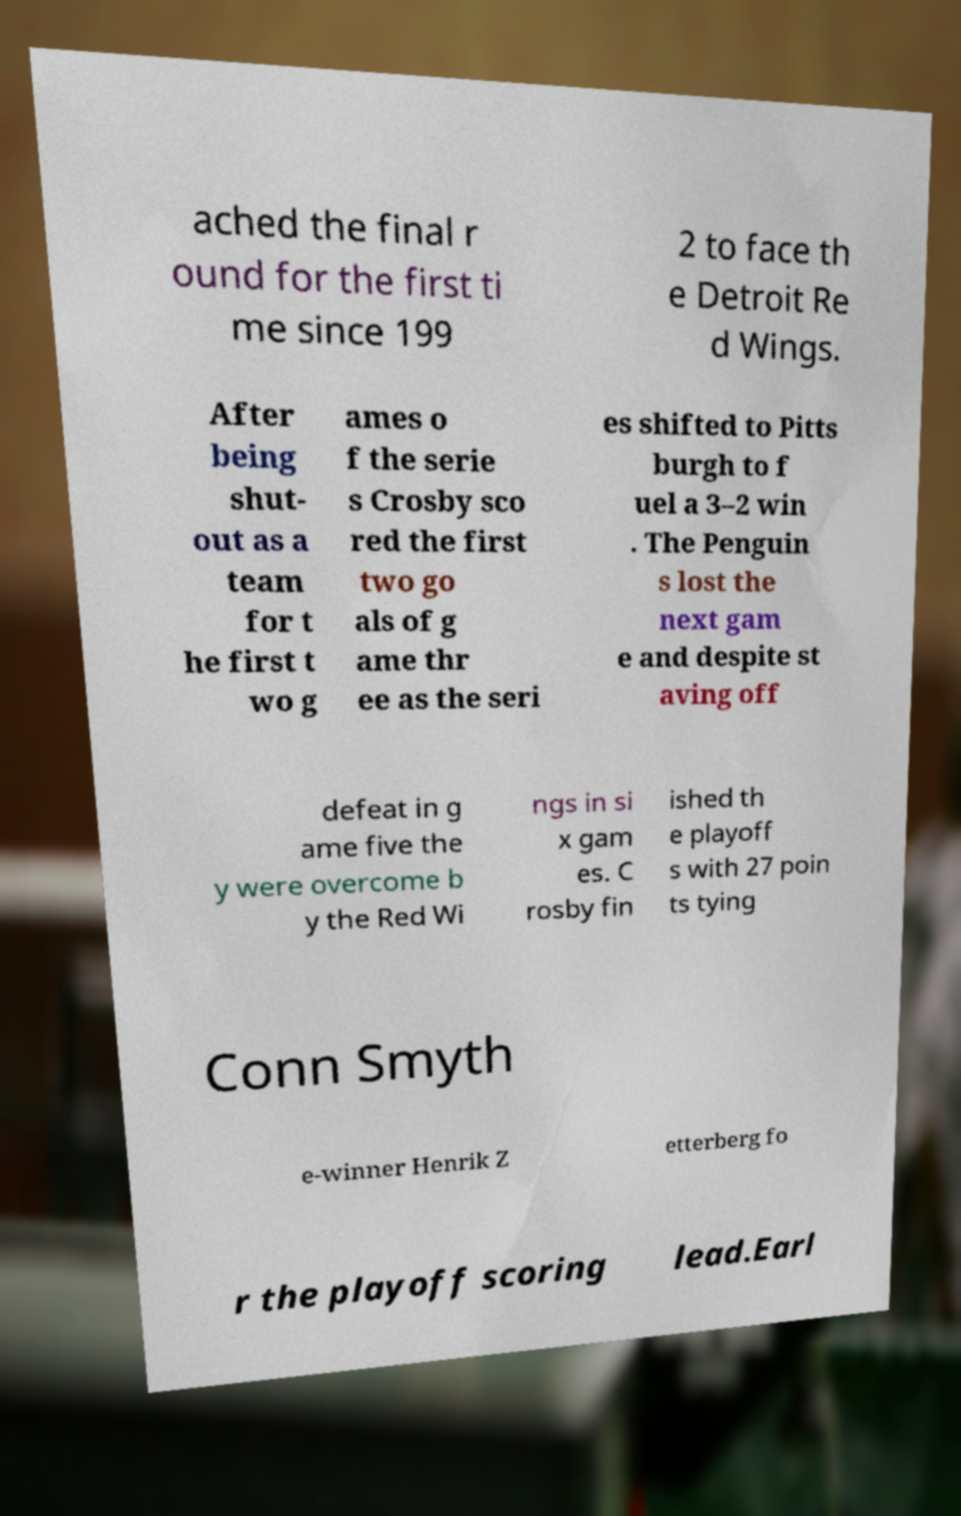For documentation purposes, I need the text within this image transcribed. Could you provide that? ached the final r ound for the first ti me since 199 2 to face th e Detroit Re d Wings. After being shut- out as a team for t he first t wo g ames o f the serie s Crosby sco red the first two go als of g ame thr ee as the seri es shifted to Pitts burgh to f uel a 3–2 win . The Penguin s lost the next gam e and despite st aving off defeat in g ame five the y were overcome b y the Red Wi ngs in si x gam es. C rosby fin ished th e playoff s with 27 poin ts tying Conn Smyth e-winner Henrik Z etterberg fo r the playoff scoring lead.Earl 